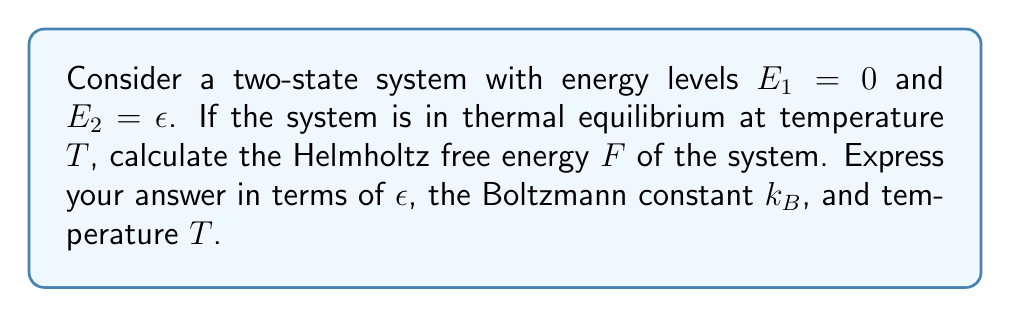Could you help me with this problem? To solve this problem, we'll follow these steps:

1) The partition function $Z$ for a two-state system is given by:
   $$Z = e^{-\beta E_1} + e^{-\beta E_2}$$
   where $\beta = \frac{1}{k_B T}$

2) Substituting the given energy levels:
   $$Z = e^{-\beta \cdot 0} + e^{-\beta \epsilon} = 1 + e^{-\beta \epsilon}$$

3) The Helmholtz free energy $F$ is related to the partition function by:
   $$F = -k_B T \ln Z$$

4) Substituting our expression for $Z$:
   $$F = -k_B T \ln(1 + e^{-\beta \epsilon})$$

5) Expanding $\beta$:
   $$F = -k_B T \ln(1 + e^{-\epsilon/(k_B T)})$$

This is our final expression for the Helmholtz free energy of the system.
Answer: $F = -k_B T \ln(1 + e^{-\epsilon/(k_B T)})$ 